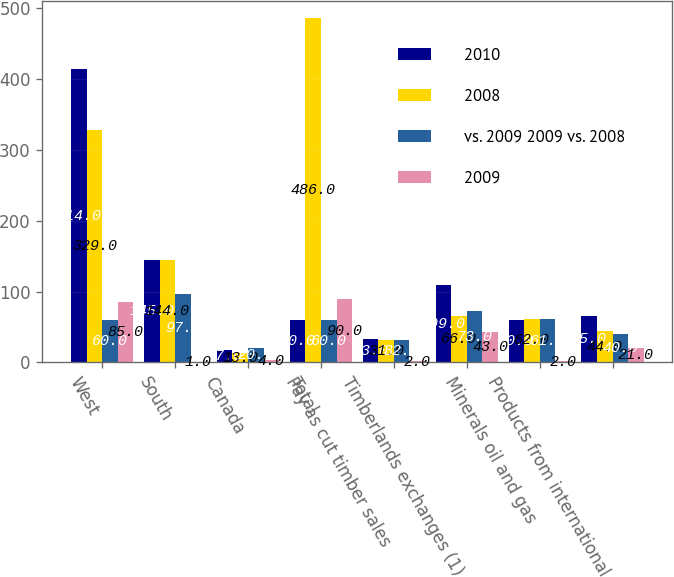Convert chart. <chart><loc_0><loc_0><loc_500><loc_500><stacked_bar_chart><ecel><fcel>West<fcel>South<fcel>Canada<fcel>Total<fcel>Pay as cut timber sales<fcel>Timberlands exchanges (1)<fcel>Minerals oil and gas<fcel>Products from international<nl><fcel>2010<fcel>414<fcel>145<fcel>17<fcel>60<fcel>33<fcel>109<fcel>60<fcel>65<nl><fcel>2008<fcel>329<fcel>144<fcel>13<fcel>486<fcel>31<fcel>66<fcel>62<fcel>44<nl><fcel>vs. 2009 2009 vs. 2008<fcel>60<fcel>97<fcel>20<fcel>60<fcel>32<fcel>73<fcel>61<fcel>40<nl><fcel>2009<fcel>85<fcel>1<fcel>4<fcel>90<fcel>2<fcel>43<fcel>2<fcel>21<nl></chart> 